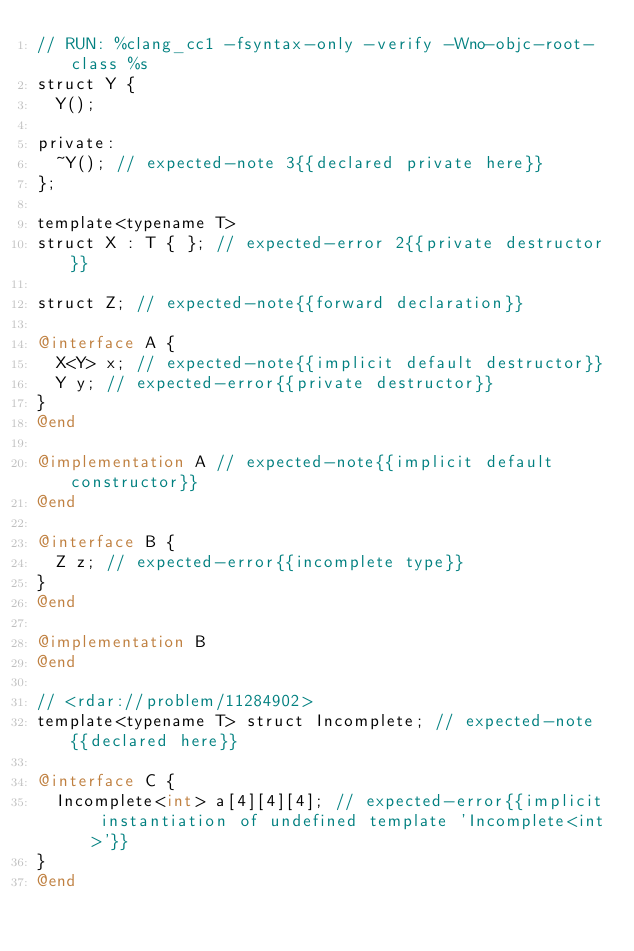<code> <loc_0><loc_0><loc_500><loc_500><_ObjectiveC_>// RUN: %clang_cc1 -fsyntax-only -verify -Wno-objc-root-class %s
struct Y { 
  Y(); 

private:
  ~Y(); // expected-note 3{{declared private here}}
};

template<typename T>
struct X : T { }; // expected-error 2{{private destructor}}

struct Z; // expected-note{{forward declaration}}

@interface A {
  X<Y> x; // expected-note{{implicit default destructor}}
  Y y; // expected-error{{private destructor}}
}
@end

@implementation A // expected-note{{implicit default constructor}}
@end

@interface B {
  Z z; // expected-error{{incomplete type}}
}
@end

@implementation B
@end

// <rdar://problem/11284902>
template<typename T> struct Incomplete; // expected-note{{declared here}}

@interface C {
  Incomplete<int> a[4][4][4]; // expected-error{{implicit instantiation of undefined template 'Incomplete<int>'}}
}
@end
</code> 